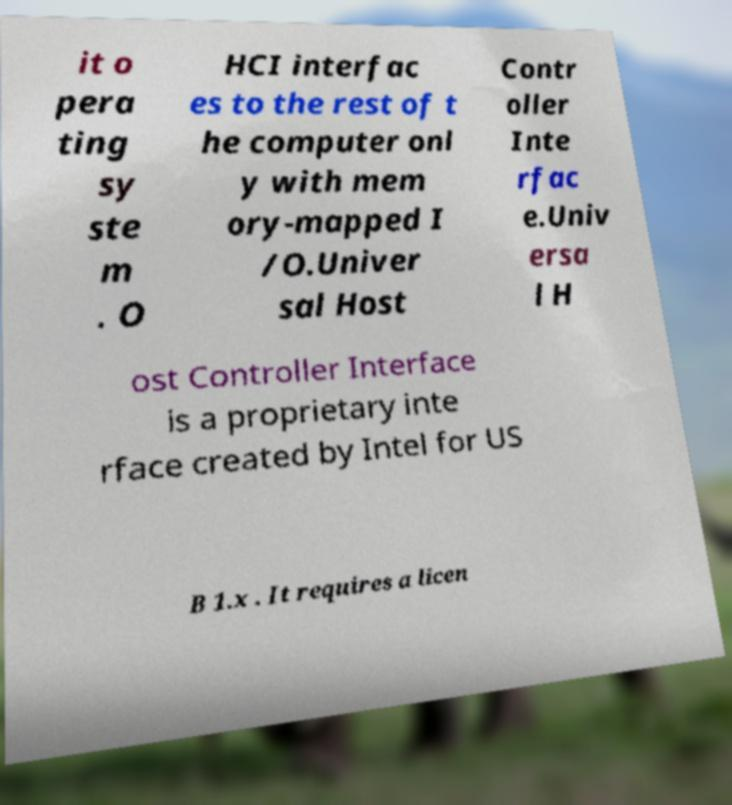I need the written content from this picture converted into text. Can you do that? it o pera ting sy ste m . O HCI interfac es to the rest of t he computer onl y with mem ory-mapped I /O.Univer sal Host Contr oller Inte rfac e.Univ ersa l H ost Controller Interface is a proprietary inte rface created by Intel for US B 1.x . It requires a licen 